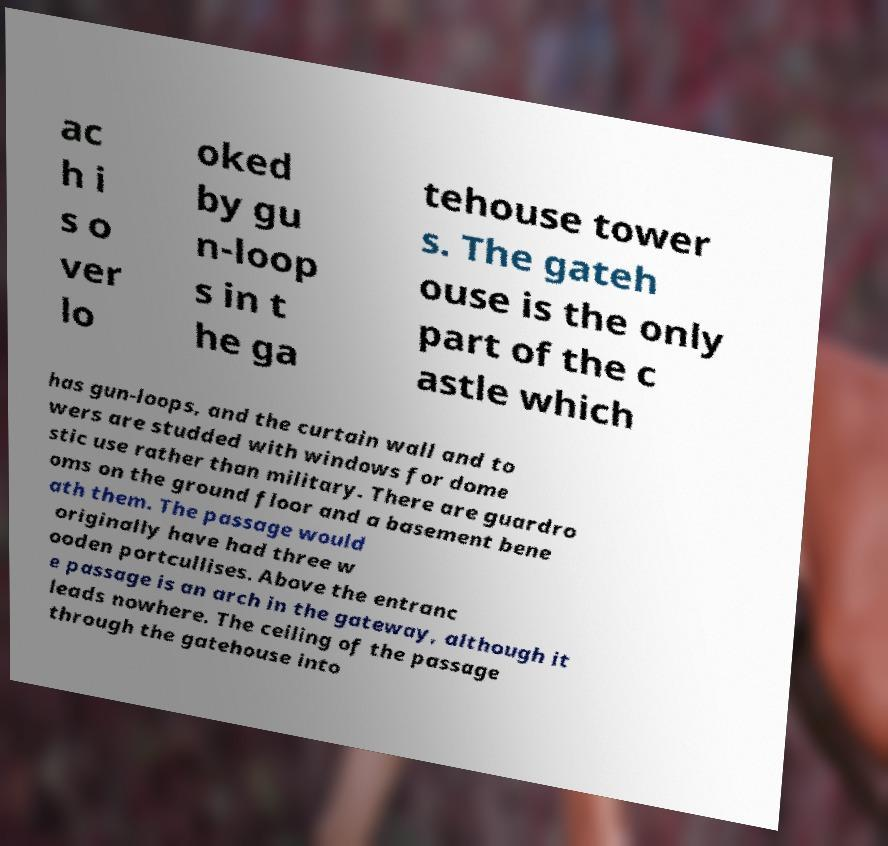Could you extract and type out the text from this image? ac h i s o ver lo oked by gu n-loop s in t he ga tehouse tower s. The gateh ouse is the only part of the c astle which has gun-loops, and the curtain wall and to wers are studded with windows for dome stic use rather than military. There are guardro oms on the ground floor and a basement bene ath them. The passage would originally have had three w ooden portcullises. Above the entranc e passage is an arch in the gateway, although it leads nowhere. The ceiling of the passage through the gatehouse into 